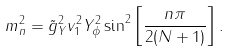Convert formula to latex. <formula><loc_0><loc_0><loc_500><loc_500>m _ { n } ^ { 2 } = \tilde { g } _ { Y } ^ { 2 } v _ { 1 } ^ { 2 } Y _ { \phi } ^ { 2 } \sin ^ { 2 } \left [ \frac { n \pi } { 2 ( N + 1 ) } \right ] .</formula> 